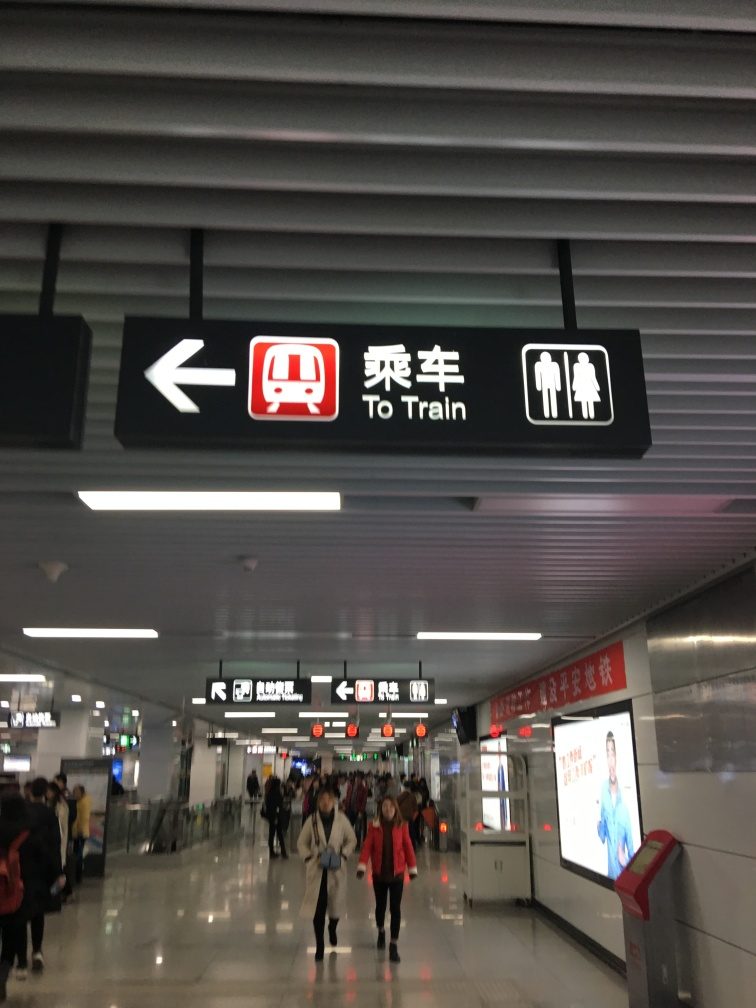What information does the image convey about the location's functionality? The primary function of this location is to facilitate the movement of passengers to their respective destinations. The signs serve as guidance tools, indicating the direction passengers should take to reach the trains and restrooms. The presence of multiple signs and symbols suggests a well-organized space designed to accommodate a high volume of travelers and help them find their way with ease. The barriers and wide corridors indicate controlled access points to platforms, enhancing security and passenger flow management. 